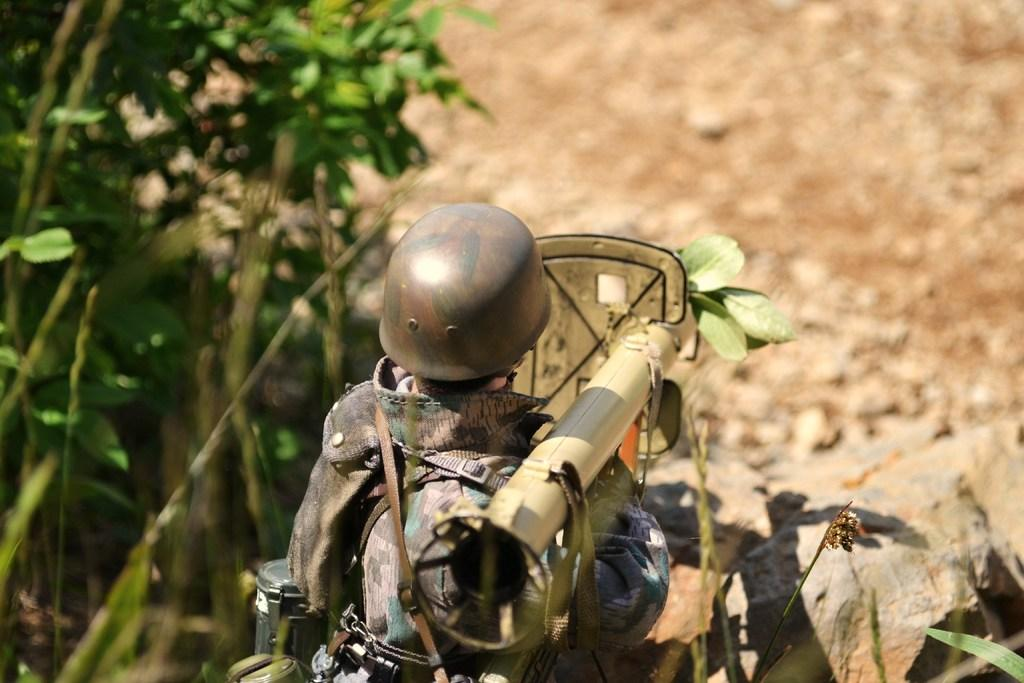What is the person in the image wearing on their head? The person is wearing a helmet in the image. Where is the person located in the image? The person is in the center of the image. What can be seen on the right side of the image? There are stones on the right side of the image. What type of vegetation is on the left side of the image? There are trees on the left side of the image. What type of branch can be seen hanging from the ceiling in the image? There is no branch hanging from the ceiling in the image; it features a person wearing a helmet in the center, with stones on the right side and trees on the left side. 